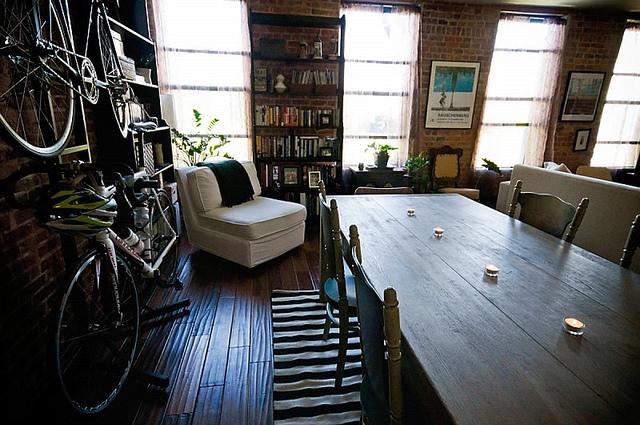Is there a table in the image?
Quick response, please. Yes. How many candles are on the table?
Give a very brief answer. 4. Why is the bike on the wall?
Write a very short answer. Storage. 